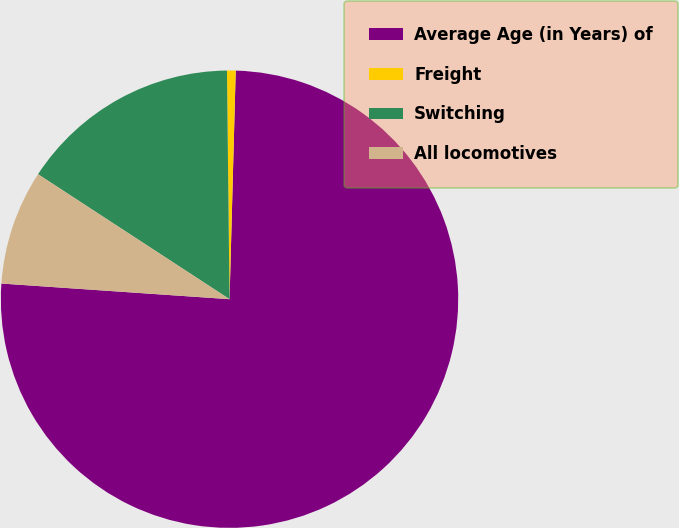<chart> <loc_0><loc_0><loc_500><loc_500><pie_chart><fcel>Average Age (in Years) of<fcel>Freight<fcel>Switching<fcel>All locomotives<nl><fcel>75.66%<fcel>0.61%<fcel>15.62%<fcel>8.11%<nl></chart> 